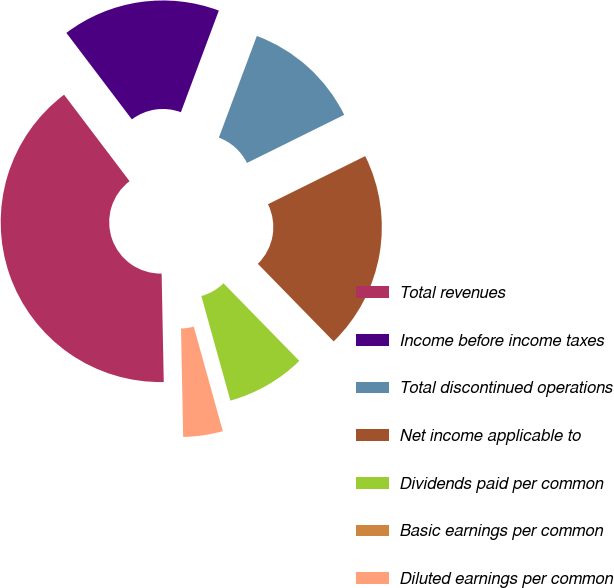Convert chart. <chart><loc_0><loc_0><loc_500><loc_500><pie_chart><fcel>Total revenues<fcel>Income before income taxes<fcel>Total discontinued operations<fcel>Net income applicable to<fcel>Dividends paid per common<fcel>Basic earnings per common<fcel>Diluted earnings per common<nl><fcel>40.0%<fcel>16.0%<fcel>12.0%<fcel>20.0%<fcel>8.0%<fcel>0.0%<fcel>4.0%<nl></chart> 